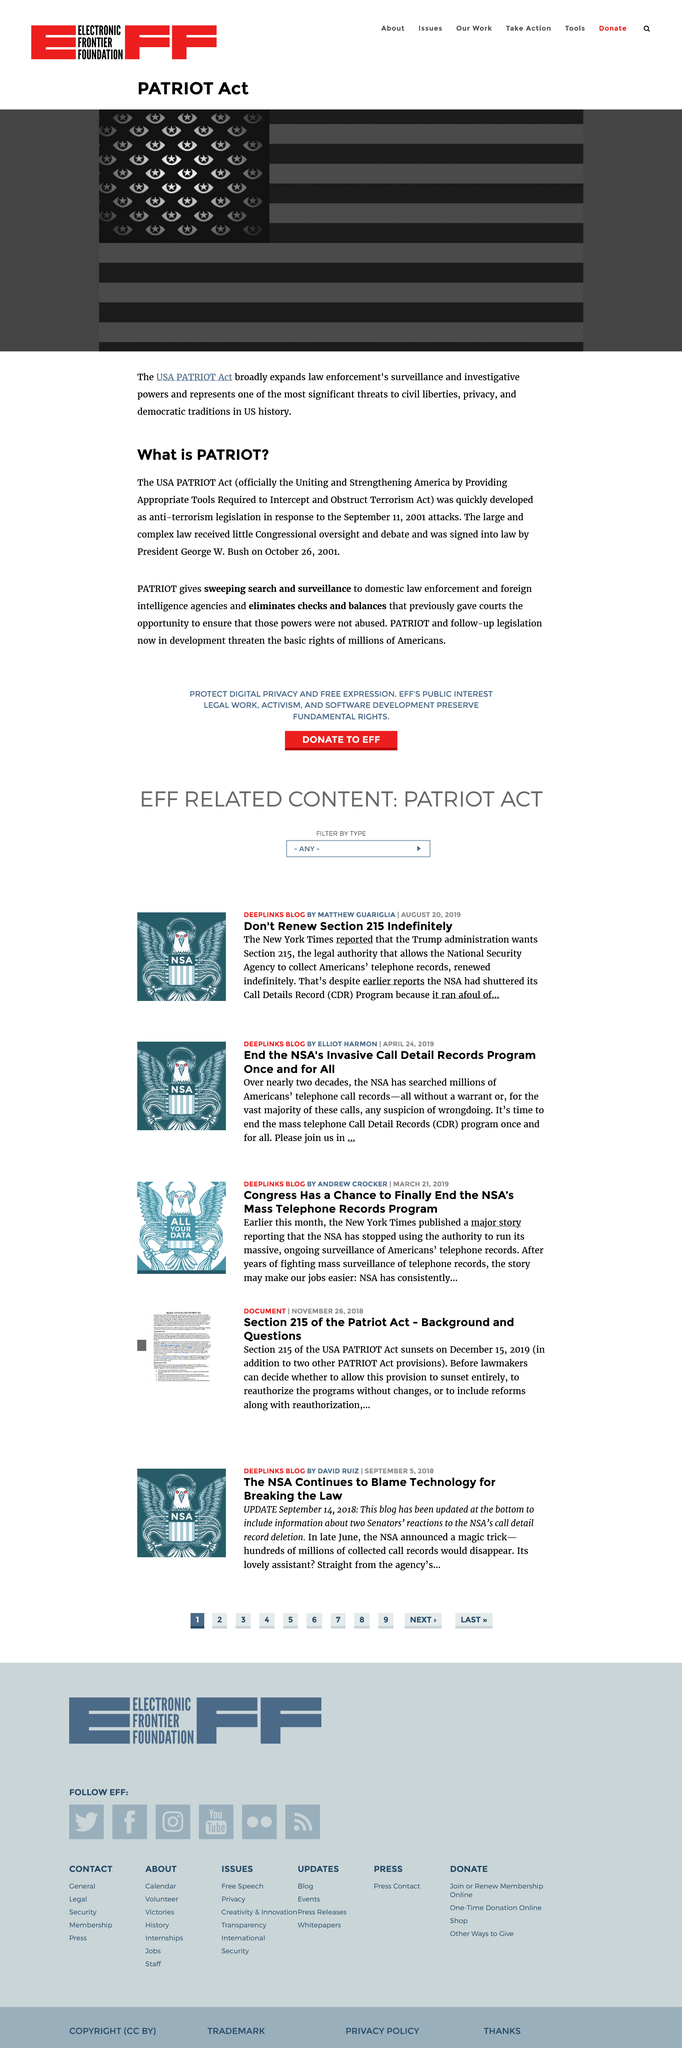Highlight a few significant elements in this photo. The President who signed the USA PATRIOT act into law was George W. Bush. I, [Your Name], declare that PATRIOT is an anti-terrorism legislation that aims to strengthen the government's power to combat terrorism and protect the country from threats. The PATRIOT Act was created in response to the 9/11 attacks as an impetus to strengthen the country's national security. 